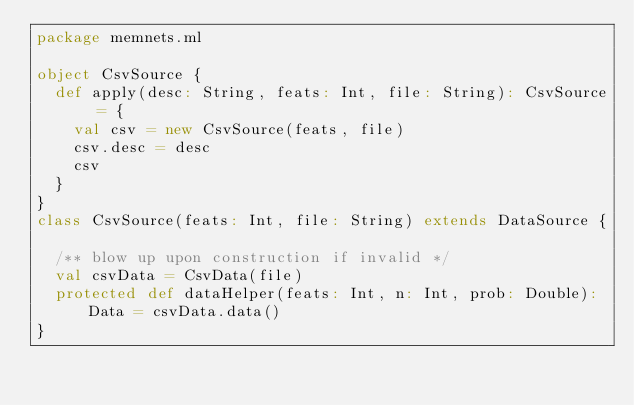Convert code to text. <code><loc_0><loc_0><loc_500><loc_500><_Scala_>package memnets.ml

object CsvSource {
  def apply(desc: String, feats: Int, file: String): CsvSource = {
    val csv = new CsvSource(feats, file)
    csv.desc = desc
    csv
  }
}
class CsvSource(feats: Int, file: String) extends DataSource {

  /** blow up upon construction if invalid */
  val csvData = CsvData(file)
  protected def dataHelper(feats: Int, n: Int, prob: Double): Data = csvData.data()
}
</code> 